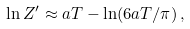Convert formula to latex. <formula><loc_0><loc_0><loc_500><loc_500>\ln Z ^ { \prime } \approx a T - \ln ( 6 a T / \pi ) \, ,</formula> 